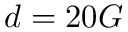Convert formula to latex. <formula><loc_0><loc_0><loc_500><loc_500>d = 2 0 G</formula> 